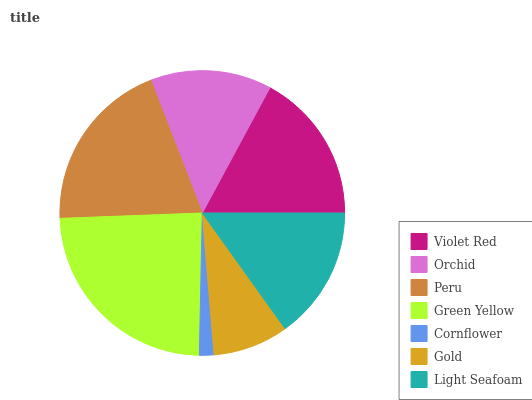Is Cornflower the minimum?
Answer yes or no. Yes. Is Green Yellow the maximum?
Answer yes or no. Yes. Is Orchid the minimum?
Answer yes or no. No. Is Orchid the maximum?
Answer yes or no. No. Is Violet Red greater than Orchid?
Answer yes or no. Yes. Is Orchid less than Violet Red?
Answer yes or no. Yes. Is Orchid greater than Violet Red?
Answer yes or no. No. Is Violet Red less than Orchid?
Answer yes or no. No. Is Light Seafoam the high median?
Answer yes or no. Yes. Is Light Seafoam the low median?
Answer yes or no. Yes. Is Orchid the high median?
Answer yes or no. No. Is Cornflower the low median?
Answer yes or no. No. 